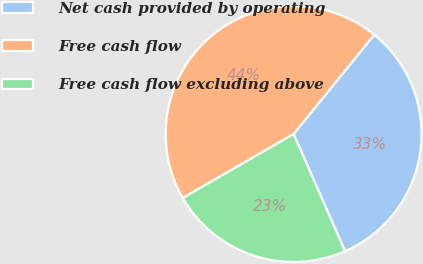Convert chart. <chart><loc_0><loc_0><loc_500><loc_500><pie_chart><fcel>Net cash provided by operating<fcel>Free cash flow<fcel>Free cash flow excluding above<nl><fcel>32.56%<fcel>44.19%<fcel>23.26%<nl></chart> 